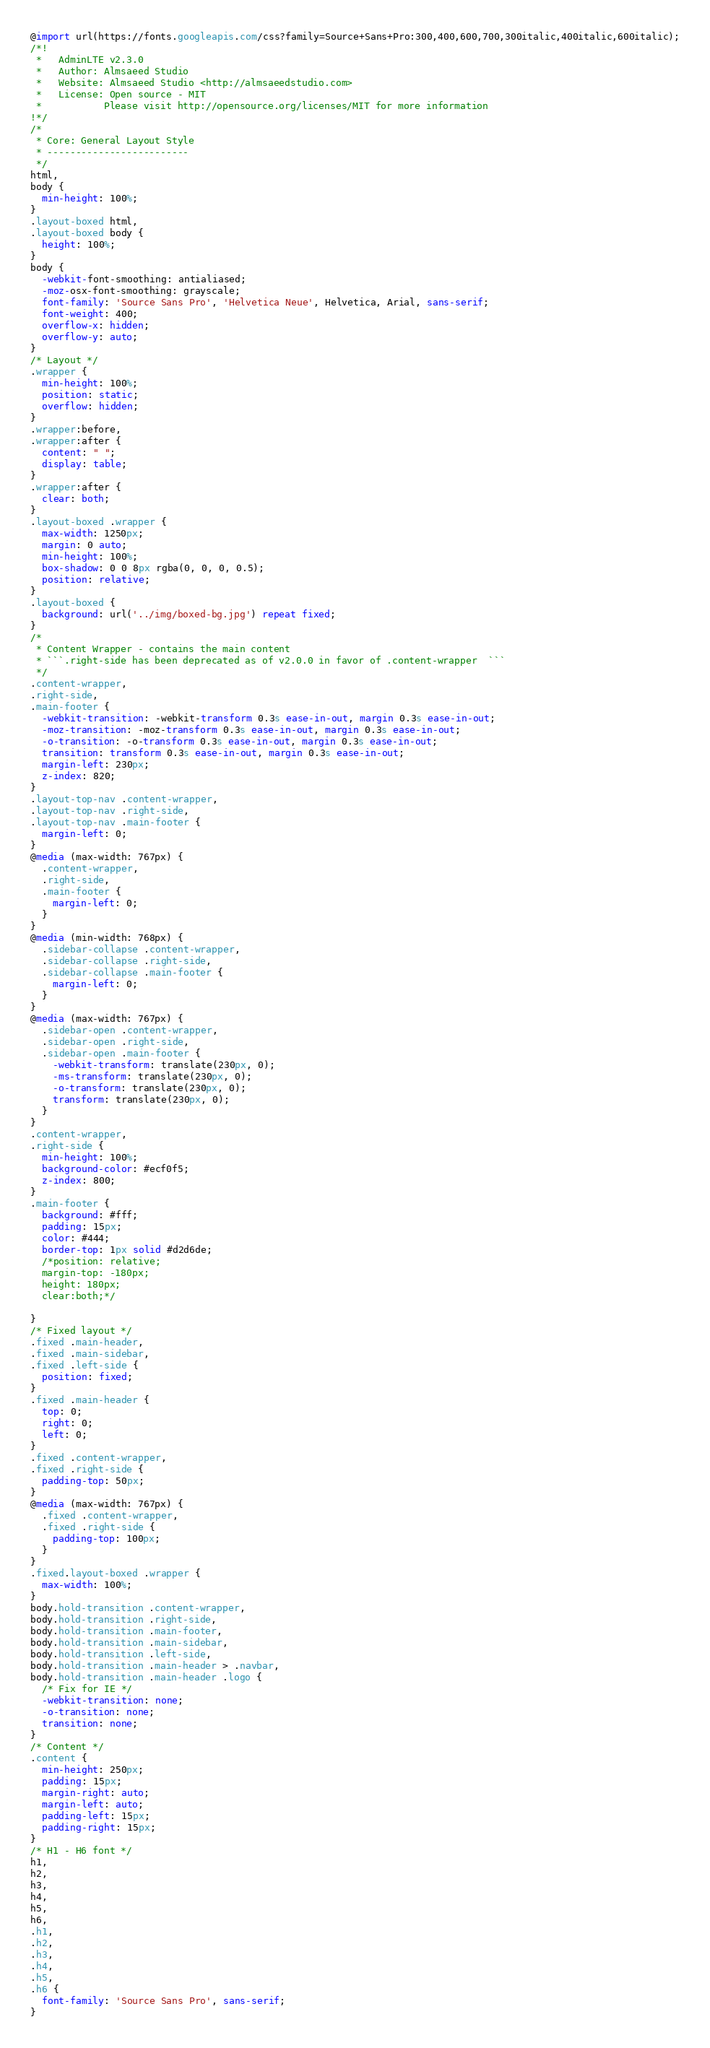<code> <loc_0><loc_0><loc_500><loc_500><_CSS_>@import url(https://fonts.googleapis.com/css?family=Source+Sans+Pro:300,400,600,700,300italic,400italic,600italic);
/*!
 *   AdminLTE v2.3.0
 *   Author: Almsaeed Studio
 *	 Website: Almsaeed Studio <http://almsaeedstudio.com>
 *   License: Open source - MIT
 *           Please visit http://opensource.org/licenses/MIT for more information
!*/
/*
 * Core: General Layout Style
 * -------------------------
 */
html,
body {
  min-height: 100%;
}
.layout-boxed html,
.layout-boxed body {
  height: 100%;
}
body {
  -webkit-font-smoothing: antialiased;
  -moz-osx-font-smoothing: grayscale;
  font-family: 'Source Sans Pro', 'Helvetica Neue', Helvetica, Arial, sans-serif;
  font-weight: 400;
  overflow-x: hidden;
  overflow-y: auto;
}
/* Layout */
.wrapper {
  min-height: 100%;
  position: static;
  overflow: hidden;
}
.wrapper:before,
.wrapper:after {
  content: " ";
  display: table;
}
.wrapper:after {
  clear: both;
}
.layout-boxed .wrapper {
  max-width: 1250px;
  margin: 0 auto;
  min-height: 100%;
  box-shadow: 0 0 8px rgba(0, 0, 0, 0.5);
  position: relative;
}
.layout-boxed {
  background: url('../img/boxed-bg.jpg') repeat fixed;
}
/*
 * Content Wrapper - contains the main content
 * ```.right-side has been deprecated as of v2.0.0 in favor of .content-wrapper  ```
 */
.content-wrapper,
.right-side,
.main-footer {
  -webkit-transition: -webkit-transform 0.3s ease-in-out, margin 0.3s ease-in-out;
  -moz-transition: -moz-transform 0.3s ease-in-out, margin 0.3s ease-in-out;
  -o-transition: -o-transform 0.3s ease-in-out, margin 0.3s ease-in-out;
  transition: transform 0.3s ease-in-out, margin 0.3s ease-in-out;
  margin-left: 230px;
  z-index: 820;
}
.layout-top-nav .content-wrapper,
.layout-top-nav .right-side,
.layout-top-nav .main-footer {
  margin-left: 0;
}
@media (max-width: 767px) {
  .content-wrapper,
  .right-side,
  .main-footer {
    margin-left: 0;
  }
}
@media (min-width: 768px) {
  .sidebar-collapse .content-wrapper,
  .sidebar-collapse .right-side,
  .sidebar-collapse .main-footer {
    margin-left: 0;
  }
}
@media (max-width: 767px) {
  .sidebar-open .content-wrapper,
  .sidebar-open .right-side,
  .sidebar-open .main-footer {
    -webkit-transform: translate(230px, 0);
    -ms-transform: translate(230px, 0);
    -o-transform: translate(230px, 0);
    transform: translate(230px, 0);
  }
}
.content-wrapper,
.right-side {
  min-height: 100%;
  background-color: #ecf0f5;
  z-index: 800;
}
.main-footer {
  background: #fff;
  padding: 15px;
  color: #444;
  border-top: 1px solid #d2d6de;
  /*position: relative;
  margin-top: -180px;
  height: 180px;
  clear:both;*/

}
/* Fixed layout */
.fixed .main-header,
.fixed .main-sidebar,
.fixed .left-side {
  position: fixed;
}
.fixed .main-header {
  top: 0;
  right: 0;
  left: 0;
}
.fixed .content-wrapper,
.fixed .right-side {
  padding-top: 50px;
}
@media (max-width: 767px) {
  .fixed .content-wrapper,
  .fixed .right-side {
    padding-top: 100px;
  }
}
.fixed.layout-boxed .wrapper {
  max-width: 100%;
}
body.hold-transition .content-wrapper,
body.hold-transition .right-side,
body.hold-transition .main-footer,
body.hold-transition .main-sidebar,
body.hold-transition .left-side,
body.hold-transition .main-header > .navbar,
body.hold-transition .main-header .logo {
  /* Fix for IE */
  -webkit-transition: none;
  -o-transition: none;
  transition: none;
}
/* Content */
.content {
  min-height: 250px;
  padding: 15px;
  margin-right: auto;
  margin-left: auto;
  padding-left: 15px;
  padding-right: 15px;
}
/* H1 - H6 font */
h1,
h2,
h3,
h4,
h5,
h6,
.h1,
.h2,
.h3,
.h4,
.h5,
.h6 {
  font-family: 'Source Sans Pro', sans-serif;
}</code> 